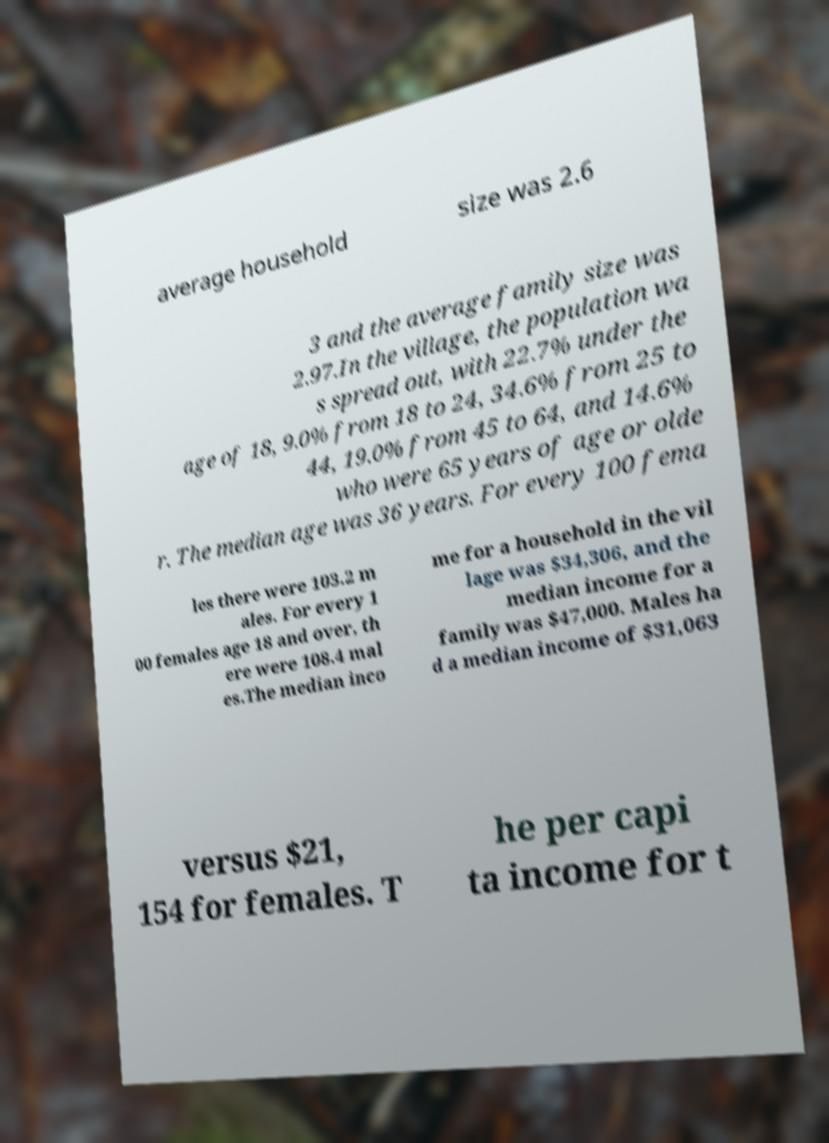I need the written content from this picture converted into text. Can you do that? average household size was 2.6 3 and the average family size was 2.97.In the village, the population wa s spread out, with 22.7% under the age of 18, 9.0% from 18 to 24, 34.6% from 25 to 44, 19.0% from 45 to 64, and 14.6% who were 65 years of age or olde r. The median age was 36 years. For every 100 fema les there were 103.2 m ales. For every 1 00 females age 18 and over, th ere were 108.4 mal es.The median inco me for a household in the vil lage was $34,306, and the median income for a family was $47,000. Males ha d a median income of $31,063 versus $21, 154 for females. T he per capi ta income for t 